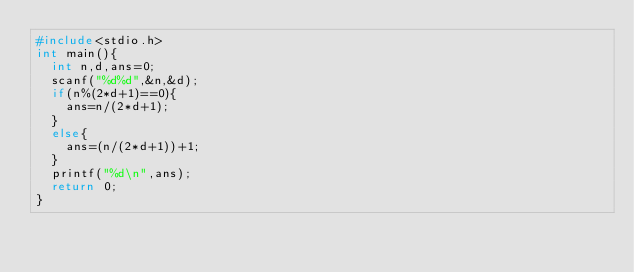Convert code to text. <code><loc_0><loc_0><loc_500><loc_500><_C_>#include<stdio.h>
int main(){
  int n,d,ans=0;
  scanf("%d%d",&n,&d);
  if(n%(2*d+1)==0){
    ans=n/(2*d+1);
  }
  else{
    ans=(n/(2*d+1))+1;
  }
  printf("%d\n",ans);
  return 0;
}
</code> 